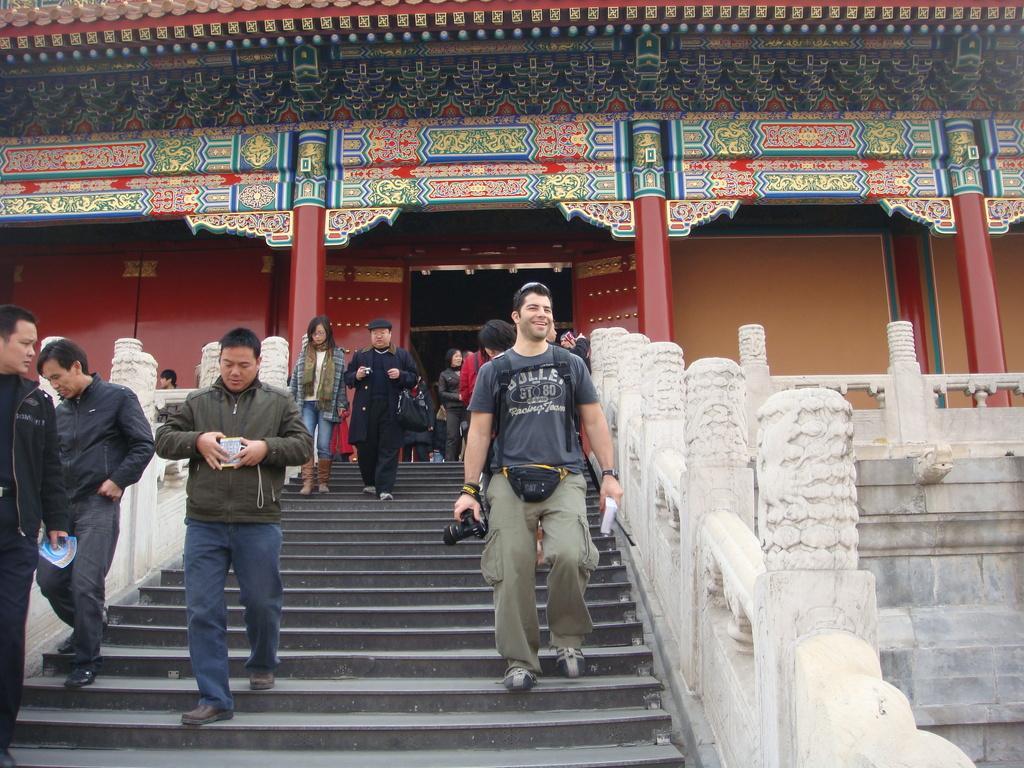Could you give a brief overview of what you see in this image? In this picture we can see some people are walking on the steps and some people are standing on the path. A man is holding a camera and an object. On the left and right side people there are walls. Behind the people there is a building and poles. 